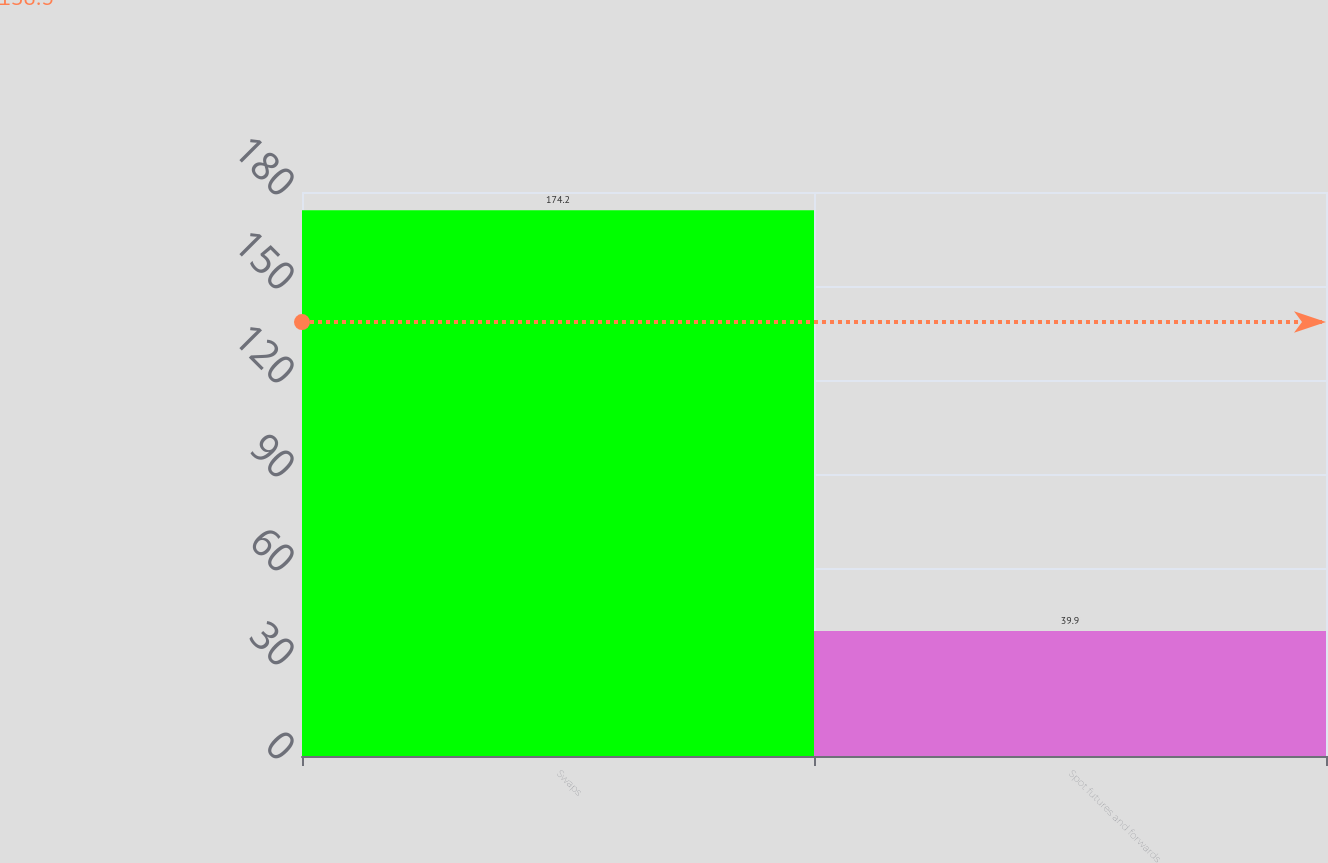Convert chart. <chart><loc_0><loc_0><loc_500><loc_500><bar_chart><fcel>Swaps<fcel>Spot futures and forwards<nl><fcel>174.2<fcel>39.9<nl></chart> 